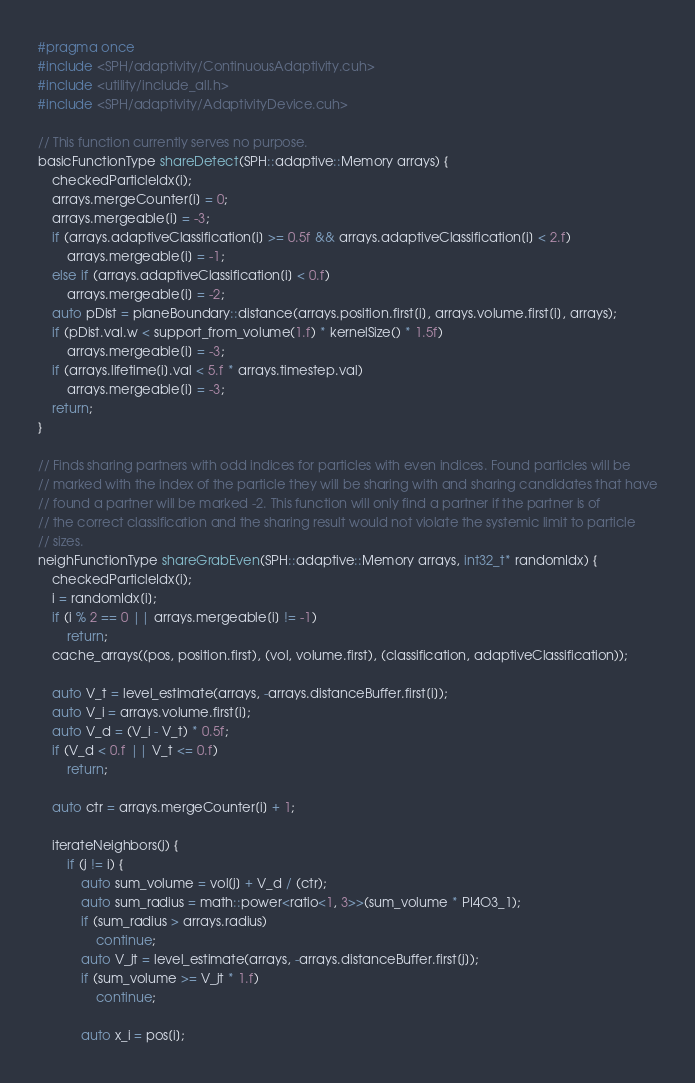Convert code to text. <code><loc_0><loc_0><loc_500><loc_500><_Cuda_>#pragma once 
#include <SPH/adaptivity/ContinuousAdaptivity.cuh>
#include <utility/include_all.h>
#include <SPH/adaptivity/AdaptivityDevice.cuh>

// This function currently serves no purpose.
basicFunctionType shareDetect(SPH::adaptive::Memory arrays) {
	checkedParticleIdx(i);
	arrays.mergeCounter[i] = 0;
	arrays.mergeable[i] = -3;
	if (arrays.adaptiveClassification[i] >= 0.5f && arrays.adaptiveClassification[i] < 2.f)
		arrays.mergeable[i] = -1;
	else if (arrays.adaptiveClassification[i] < 0.f)
		arrays.mergeable[i] = -2;
	auto pDist = planeBoundary::distance(arrays.position.first[i], arrays.volume.first[i], arrays);
	if (pDist.val.w < support_from_volume(1.f) * kernelSize() * 1.5f)
		arrays.mergeable[i] = -3;
	if (arrays.lifetime[i].val < 5.f * arrays.timestep.val)
		arrays.mergeable[i] = -3;
	return;
}

// Finds sharing partners with odd indices for particles with even indices. Found particles will be
// marked with the index of the particle they will be sharing with and sharing candidates that have
// found a partner will be marked -2. This function will only find a partner if the partner is of
// the correct classification and the sharing result would not violate the systemic limit to particle
// sizes.
neighFunctionType shareGrabEven(SPH::adaptive::Memory arrays, int32_t* randomIdx) {
	checkedParticleIdx(i);
	i = randomIdx[i];
	if (i % 2 == 0 || arrays.mergeable[i] != -1)
		return;
	cache_arrays((pos, position.first), (vol, volume.first), (classification, adaptiveClassification));

	auto V_t = level_estimate(arrays, -arrays.distanceBuffer.first[i]);
	auto V_i = arrays.volume.first[i];
	auto V_d = (V_i - V_t) * 0.5f;
	if (V_d < 0.f || V_t <= 0.f)
		return;

	auto ctr = arrays.mergeCounter[i] + 1;

	iterateNeighbors(j) {
		if (j != i) {
			auto sum_volume = vol[j] + V_d / (ctr);
			auto sum_radius = math::power<ratio<1, 3>>(sum_volume * PI4O3_1);
			if (sum_radius > arrays.radius)
				continue;
			auto V_jt = level_estimate(arrays, -arrays.distanceBuffer.first[j]);
			if (sum_volume >= V_jt * 1.f)
				continue;

			auto x_i = pos[i];</code> 